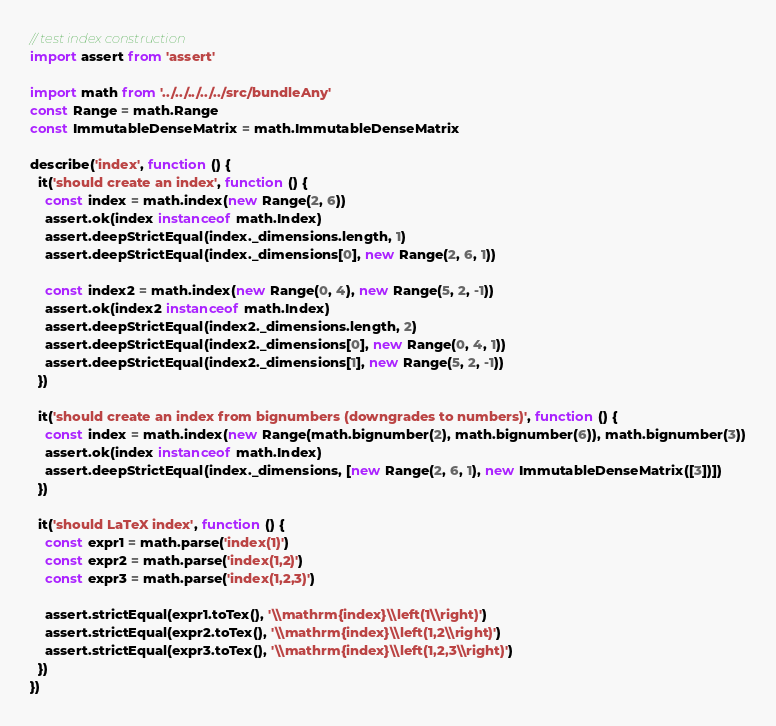<code> <loc_0><loc_0><loc_500><loc_500><_JavaScript_>// test index construction
import assert from 'assert'

import math from '../../../../../src/bundleAny'
const Range = math.Range
const ImmutableDenseMatrix = math.ImmutableDenseMatrix

describe('index', function () {
  it('should create an index', function () {
    const index = math.index(new Range(2, 6))
    assert.ok(index instanceof math.Index)
    assert.deepStrictEqual(index._dimensions.length, 1)
    assert.deepStrictEqual(index._dimensions[0], new Range(2, 6, 1))

    const index2 = math.index(new Range(0, 4), new Range(5, 2, -1))
    assert.ok(index2 instanceof math.Index)
    assert.deepStrictEqual(index2._dimensions.length, 2)
    assert.deepStrictEqual(index2._dimensions[0], new Range(0, 4, 1))
    assert.deepStrictEqual(index2._dimensions[1], new Range(5, 2, -1))
  })

  it('should create an index from bignumbers (downgrades to numbers)', function () {
    const index = math.index(new Range(math.bignumber(2), math.bignumber(6)), math.bignumber(3))
    assert.ok(index instanceof math.Index)
    assert.deepStrictEqual(index._dimensions, [new Range(2, 6, 1), new ImmutableDenseMatrix([3])])
  })

  it('should LaTeX index', function () {
    const expr1 = math.parse('index(1)')
    const expr2 = math.parse('index(1,2)')
    const expr3 = math.parse('index(1,2,3)')

    assert.strictEqual(expr1.toTex(), '\\mathrm{index}\\left(1\\right)')
    assert.strictEqual(expr2.toTex(), '\\mathrm{index}\\left(1,2\\right)')
    assert.strictEqual(expr3.toTex(), '\\mathrm{index}\\left(1,2,3\\right)')
  })
})
</code> 